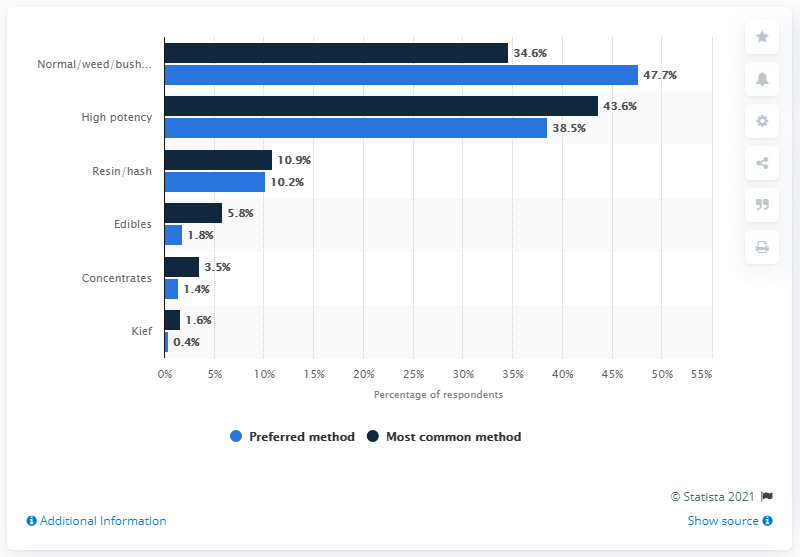Give some essential details in this illustration. Approximately 82.1% of cannabis users prefer or use high potency forms of the drug, according to a recent survey. According to a survey, 1.8% of cannabis users prefer to consume it in the edible form. 